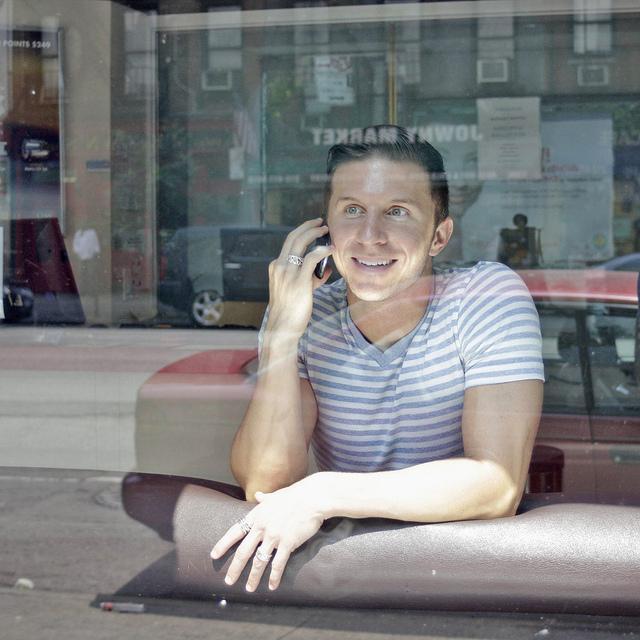How many rings is the man wearing?
Give a very brief answer. 3. How many cars are there?
Give a very brief answer. 2. How many cats are there?
Give a very brief answer. 0. 